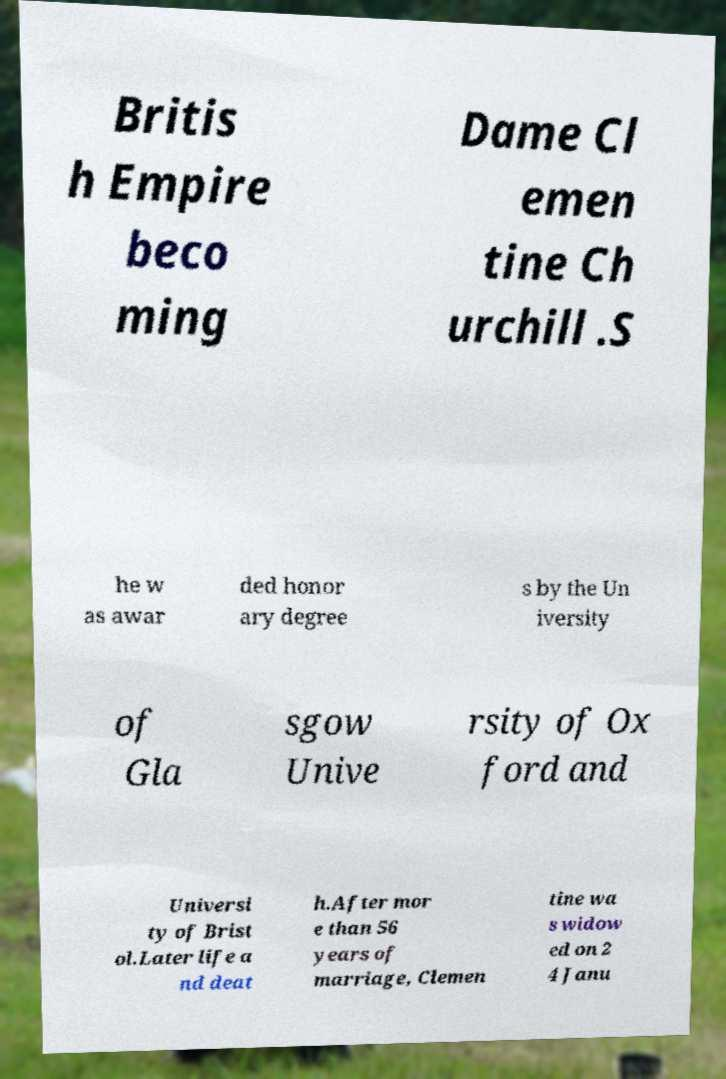Please identify and transcribe the text found in this image. Britis h Empire beco ming Dame Cl emen tine Ch urchill .S he w as awar ded honor ary degree s by the Un iversity of Gla sgow Unive rsity of Ox ford and Universi ty of Brist ol.Later life a nd deat h.After mor e than 56 years of marriage, Clemen tine wa s widow ed on 2 4 Janu 